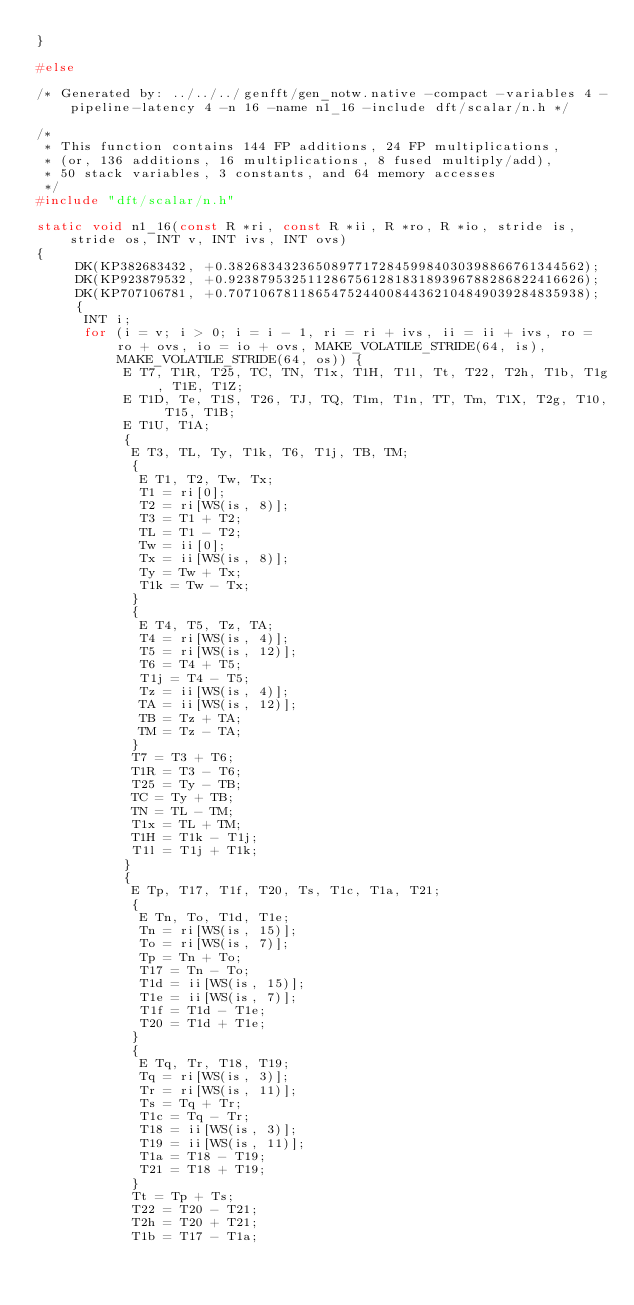<code> <loc_0><loc_0><loc_500><loc_500><_C_>}

#else

/* Generated by: ../../../genfft/gen_notw.native -compact -variables 4 -pipeline-latency 4 -n 16 -name n1_16 -include dft/scalar/n.h */

/*
 * This function contains 144 FP additions, 24 FP multiplications,
 * (or, 136 additions, 16 multiplications, 8 fused multiply/add),
 * 50 stack variables, 3 constants, and 64 memory accesses
 */
#include "dft/scalar/n.h"

static void n1_16(const R *ri, const R *ii, R *ro, R *io, stride is, stride os, INT v, INT ivs, INT ovs)
{
     DK(KP382683432, +0.382683432365089771728459984030398866761344562);
     DK(KP923879532, +0.923879532511286756128183189396788286822416626);
     DK(KP707106781, +0.707106781186547524400844362104849039284835938);
     {
	  INT i;
	  for (i = v; i > 0; i = i - 1, ri = ri + ivs, ii = ii + ivs, ro = ro + ovs, io = io + ovs, MAKE_VOLATILE_STRIDE(64, is), MAKE_VOLATILE_STRIDE(64, os)) {
	       E T7, T1R, T25, TC, TN, T1x, T1H, T1l, Tt, T22, T2h, T1b, T1g, T1E, T1Z;
	       E T1D, Te, T1S, T26, TJ, TQ, T1m, T1n, TT, Tm, T1X, T2g, T10, T15, T1B;
	       E T1U, T1A;
	       {
		    E T3, TL, Ty, T1k, T6, T1j, TB, TM;
		    {
			 E T1, T2, Tw, Tx;
			 T1 = ri[0];
			 T2 = ri[WS(is, 8)];
			 T3 = T1 + T2;
			 TL = T1 - T2;
			 Tw = ii[0];
			 Tx = ii[WS(is, 8)];
			 Ty = Tw + Tx;
			 T1k = Tw - Tx;
		    }
		    {
			 E T4, T5, Tz, TA;
			 T4 = ri[WS(is, 4)];
			 T5 = ri[WS(is, 12)];
			 T6 = T4 + T5;
			 T1j = T4 - T5;
			 Tz = ii[WS(is, 4)];
			 TA = ii[WS(is, 12)];
			 TB = Tz + TA;
			 TM = Tz - TA;
		    }
		    T7 = T3 + T6;
		    T1R = T3 - T6;
		    T25 = Ty - TB;
		    TC = Ty + TB;
		    TN = TL - TM;
		    T1x = TL + TM;
		    T1H = T1k - T1j;
		    T1l = T1j + T1k;
	       }
	       {
		    E Tp, T17, T1f, T20, Ts, T1c, T1a, T21;
		    {
			 E Tn, To, T1d, T1e;
			 Tn = ri[WS(is, 15)];
			 To = ri[WS(is, 7)];
			 Tp = Tn + To;
			 T17 = Tn - To;
			 T1d = ii[WS(is, 15)];
			 T1e = ii[WS(is, 7)];
			 T1f = T1d - T1e;
			 T20 = T1d + T1e;
		    }
		    {
			 E Tq, Tr, T18, T19;
			 Tq = ri[WS(is, 3)];
			 Tr = ri[WS(is, 11)];
			 Ts = Tq + Tr;
			 T1c = Tq - Tr;
			 T18 = ii[WS(is, 3)];
			 T19 = ii[WS(is, 11)];
			 T1a = T18 - T19;
			 T21 = T18 + T19;
		    }
		    Tt = Tp + Ts;
		    T22 = T20 - T21;
		    T2h = T20 + T21;
		    T1b = T17 - T1a;</code> 